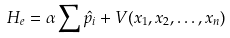Convert formula to latex. <formula><loc_0><loc_0><loc_500><loc_500>H _ { e } = \alpha \sum \hat { p } _ { i } + V ( x _ { 1 } , x _ { 2 } , \dots , x _ { n } )</formula> 